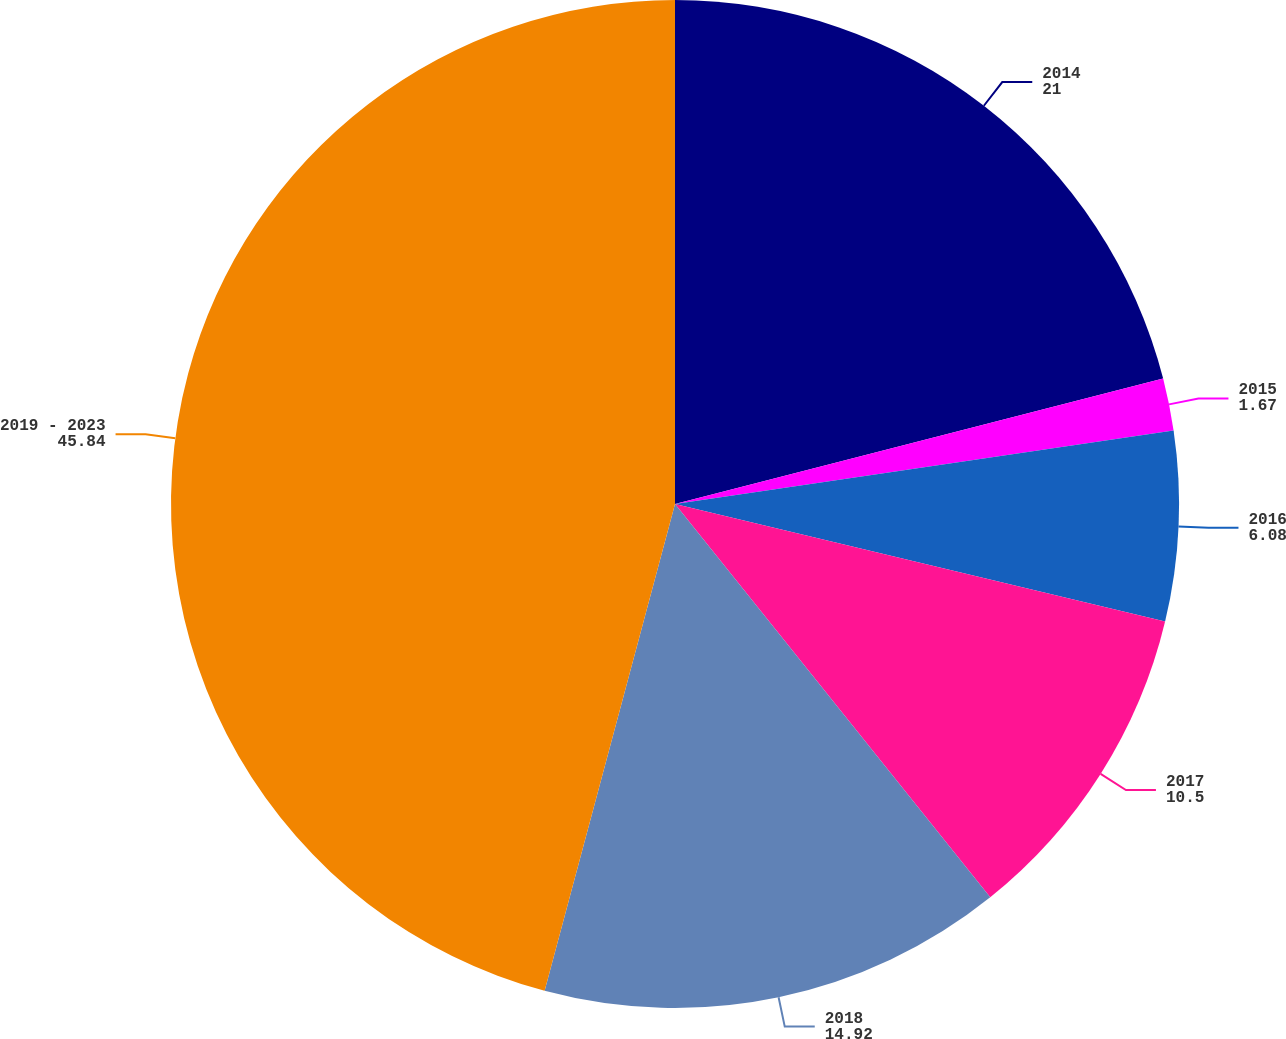Convert chart. <chart><loc_0><loc_0><loc_500><loc_500><pie_chart><fcel>2014<fcel>2015<fcel>2016<fcel>2017<fcel>2018<fcel>2019 - 2023<nl><fcel>21.0%<fcel>1.67%<fcel>6.08%<fcel>10.5%<fcel>14.92%<fcel>45.84%<nl></chart> 